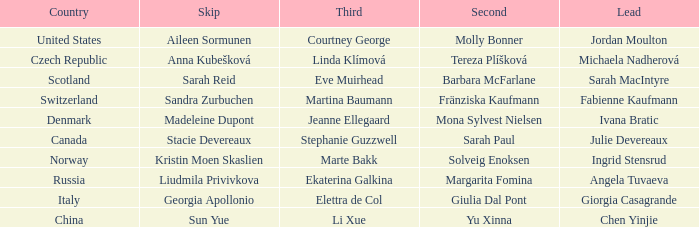What skip has martina baumann as the third? Sandra Zurbuchen. 